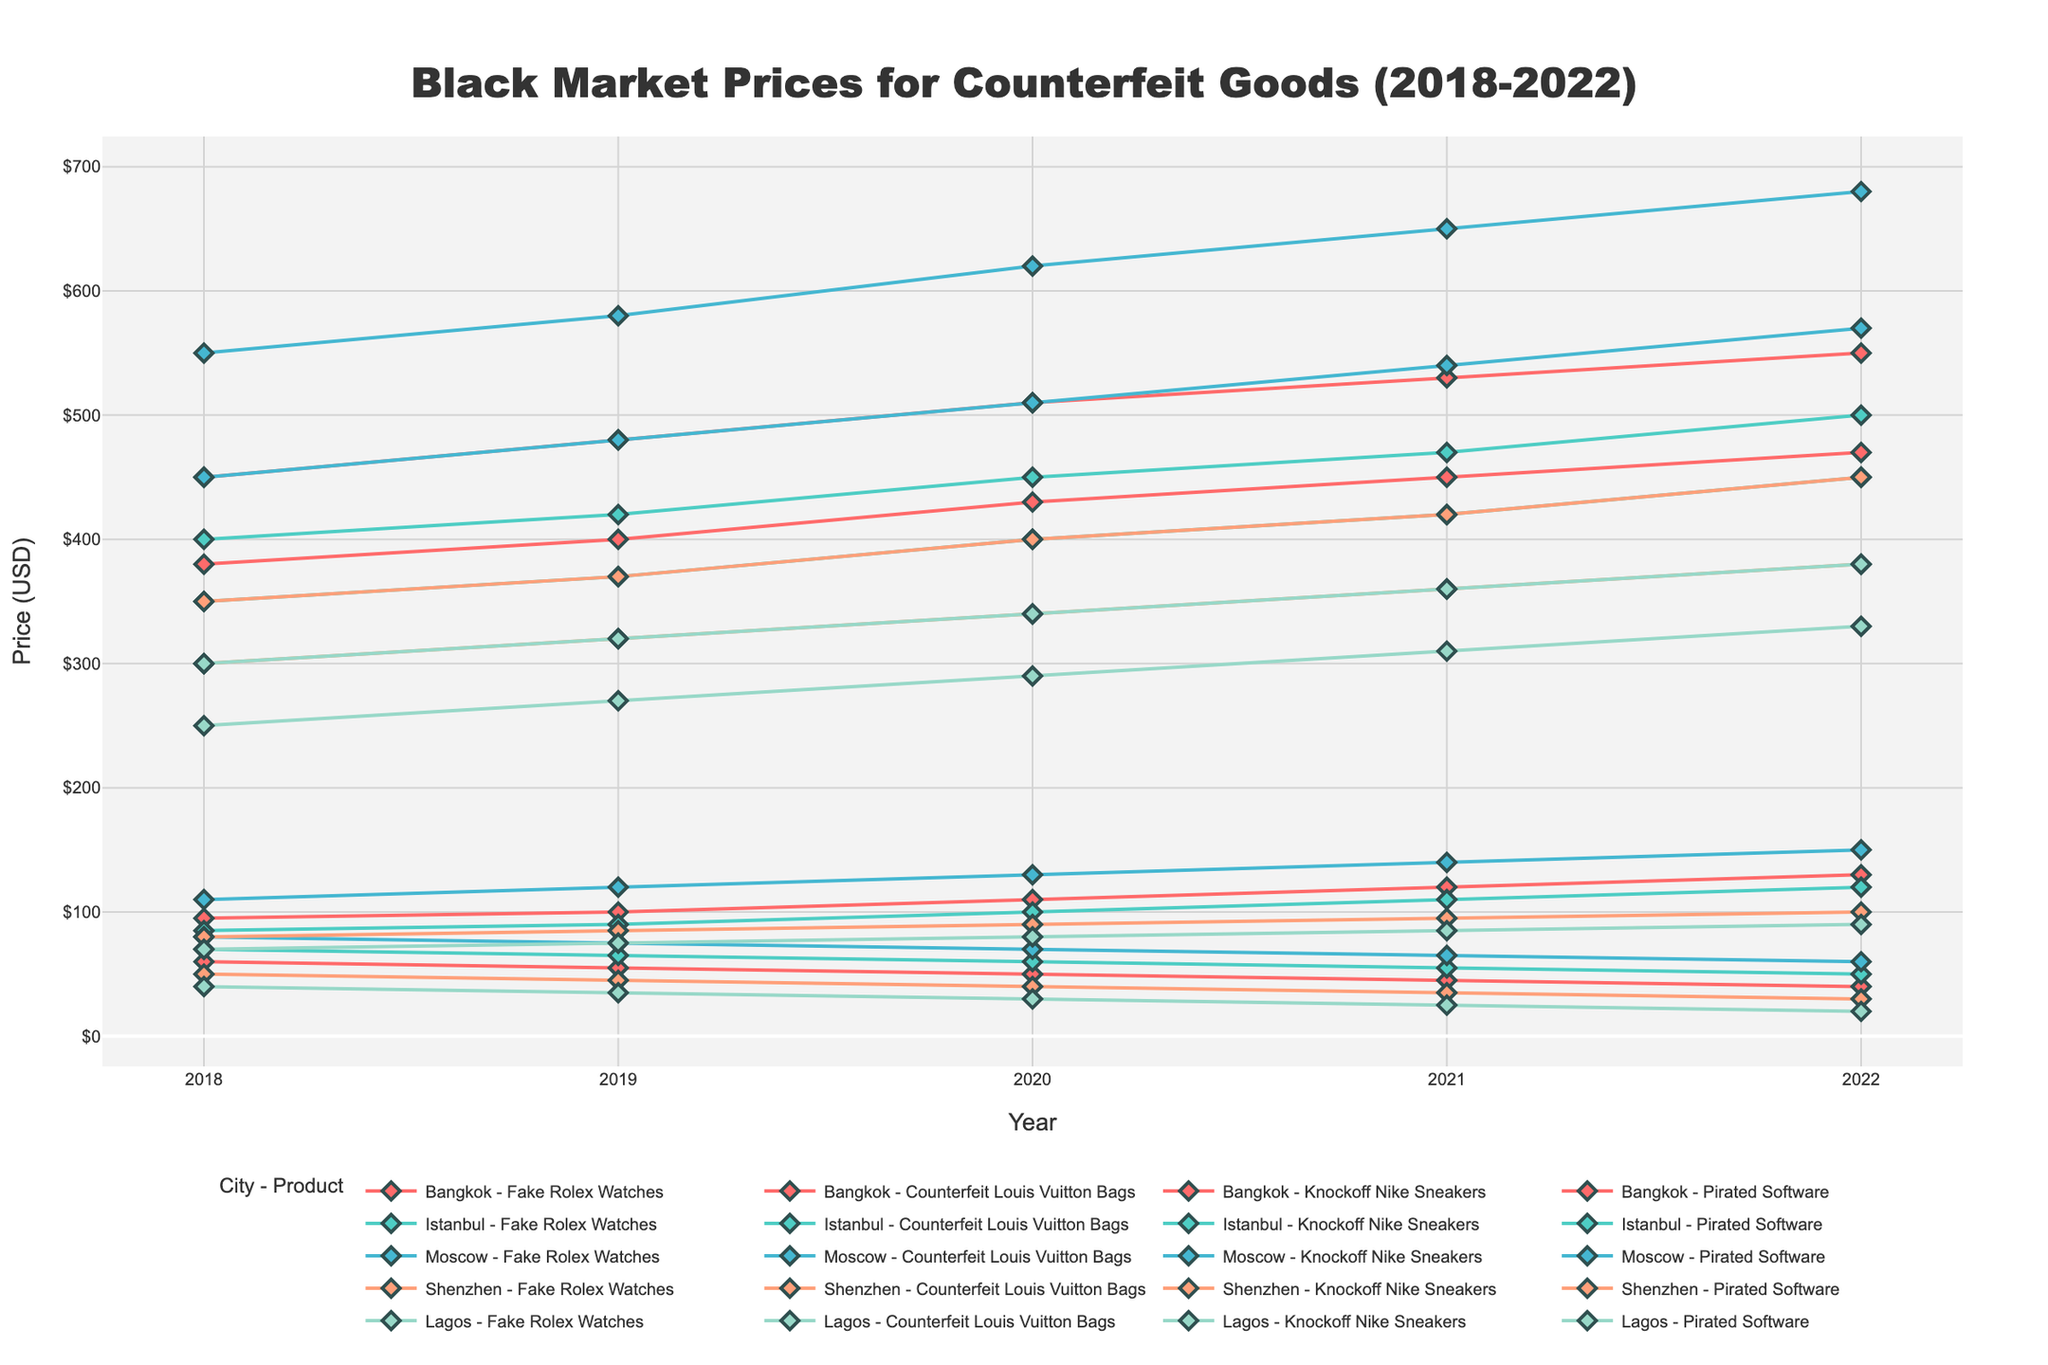What city had the highest price for Fake Rolex Watches in 2022? First, locate the line for Fake Rolex Watches. Then, identify the price for each city in 2022. Compare them to find the highest price.
Answer: Moscow Which city saw the largest price increase for Counterfeit Louis Vuitton Bags from 2018 to 2022? Calculate the price increase (2022 price - 2018 price) for each city. Compare these differences to find the largest increase.
Answer: Moscow Between 2020 and 2021, which city experienced a price drop for Pirated Software? Identify the lines for Pirated Software and check the price for each city in 2020 and 2021. Find the city where the price decreased.
Answer: Bangkok What is the trend for Knockoff Nike Sneakers prices in Shenzhen from 2018 to 2022? Track the price line for Knockoff Nike Sneakers in Shenzhen from 2018 to 2022. Observe if it’s increasing, decreasing, or stable.
Answer: Increasing What is the average price of Fake Rolex Watches in Istanbul over the years? Sum the prices of Fake Rolex Watches in Istanbul from 2018 to 2022 and divide by the number of years (5).
Answer: 448 Is there any product that experienced a consistent price decrease in any city from 2018 to 2022? If yes, specify the product and city. Look for lines that show a consistent downward trend from 2018 to 2022. Compare across all products and cities.
Answer: Pirated Software in Bangkok Which product had the smallest price increase in Lagos from 2018 to 2022? Calculate the price increase for each product in Lagos by subtracting the 2018 price from the 2022 price. Identify the smallest increase.
Answer: Knockoff Nike Sneakers Compare the price of Counterfeit Louis Vuitton Bags in Bangkok and Lagos in 2020. Which city had the higher price? Locate the prices for Counterfeit Louis Vuitton Bags in 2020 for both Bangkok and Lagos. Compare the two prices.
Answer: Bangkok For Moscow, which product's price increased the most from 2018 to 2022? Calculate the price increase for each product in Moscow by subtracting 2018 prices from 2022 prices. Identify the product with the greatest increase.
Answer: Fake Rolex Watches Among all the cities, which one had the lowest price for Knockoff Nike Sneakers in 2018? Identify the prices for Knockoff Nike Sneakers in 2018 across all cities. Compare to find the lowest price.
Answer: Lagos 